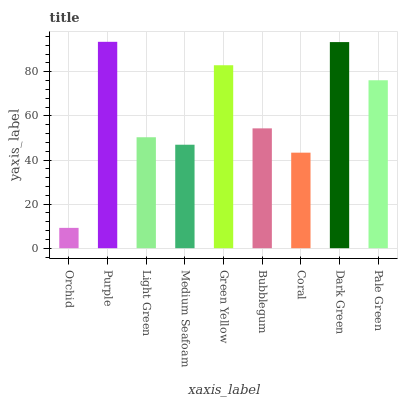Is Orchid the minimum?
Answer yes or no. Yes. Is Purple the maximum?
Answer yes or no. Yes. Is Light Green the minimum?
Answer yes or no. No. Is Light Green the maximum?
Answer yes or no. No. Is Purple greater than Light Green?
Answer yes or no. Yes. Is Light Green less than Purple?
Answer yes or no. Yes. Is Light Green greater than Purple?
Answer yes or no. No. Is Purple less than Light Green?
Answer yes or no. No. Is Bubblegum the high median?
Answer yes or no. Yes. Is Bubblegum the low median?
Answer yes or no. Yes. Is Purple the high median?
Answer yes or no. No. Is Coral the low median?
Answer yes or no. No. 